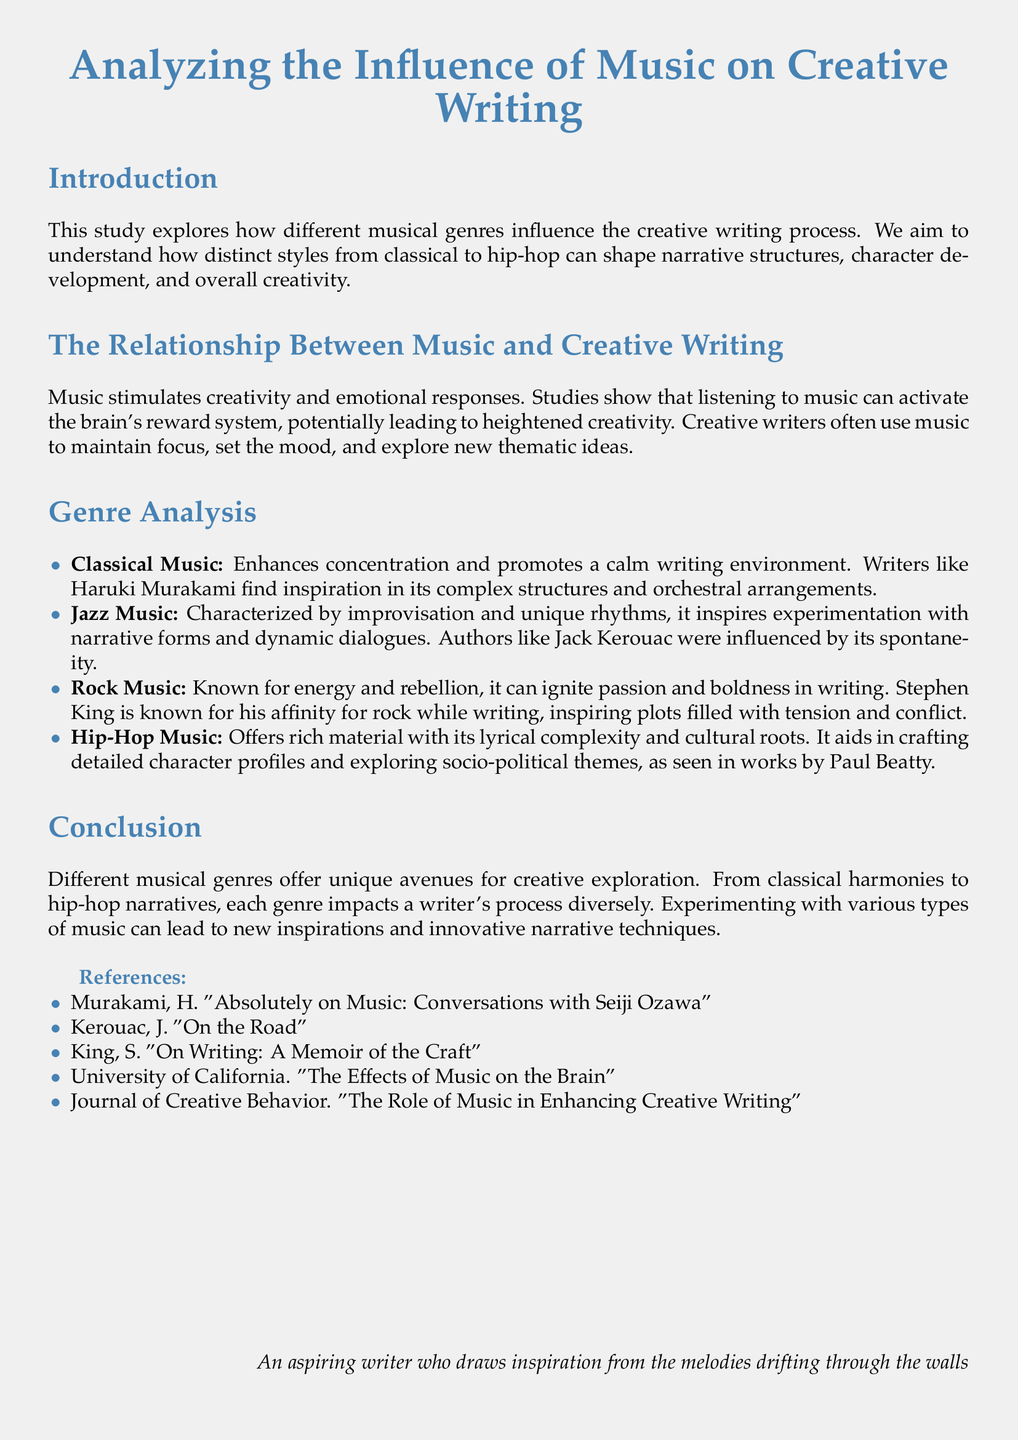What musical genre enhances concentration? The document states that classical music enhances concentration and promotes a calm writing environment.
Answer: Classical Music Which author is known for being influenced by jazz music? The document mentions Jack Kerouac as an author influenced by jazz music.
Answer: Jack Kerouac What impact does rock music have on writing, according to the document? The document describes rock music as igniting passion and boldness in writing.
Answer: Passion and boldness Which genre is associated with socio-political themes in writing? The document highlights hip-hop music as offering rich material to explore socio-political themes.
Answer: Hip-Hop Music Who authored "On Writing: A Memoir of the Craft"? The document lists Stephen King as the author of "On Writing: A Memoir of the Craft."
Answer: Stephen King What does the study aim to analyze? The document states that the study explores how different musical genres influence the creative writing process.
Answer: Influence of Music on Creative Writing Name a music genre mentioned that encourages experimentation in narrative forms. The document points to jazz music as encouraging experimentation with narrative forms and dynamic dialogues.
Answer: Jazz Music According to the study, what can listening to music activate in the brain? The document explains that listening to music can activate the brain's reward system.
Answer: Reward system What type of writing does classical music inspire, based on the document? The document mentions writers like Haruki Murakami find inspiration in the complex structures of classical music.
Answer: Complex structures 